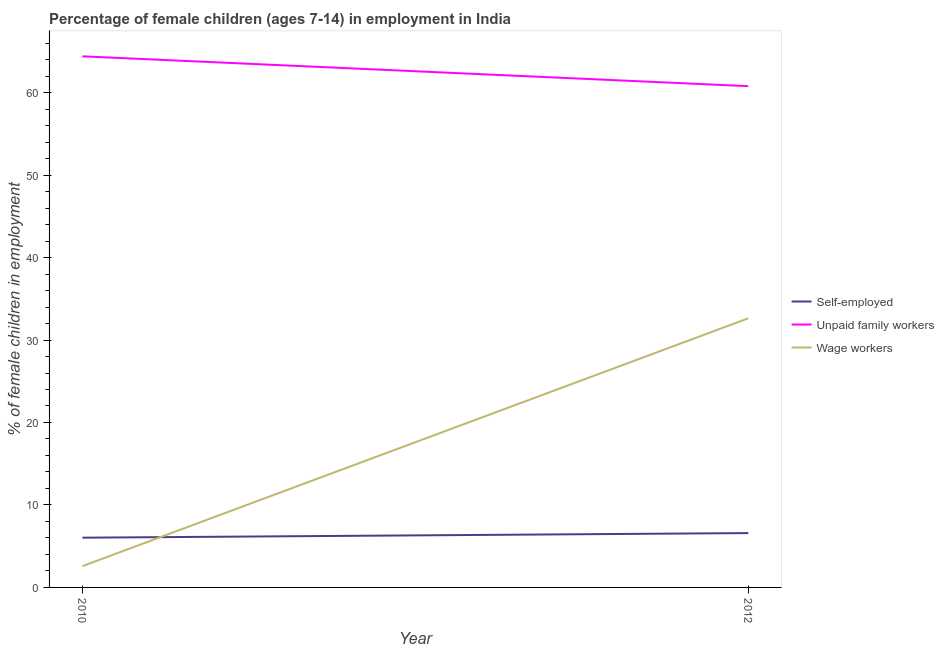How many different coloured lines are there?
Make the answer very short. 3. Is the number of lines equal to the number of legend labels?
Give a very brief answer. Yes. What is the percentage of children employed as unpaid family workers in 2010?
Your response must be concise. 64.4. Across all years, what is the maximum percentage of children employed as wage workers?
Offer a very short reply. 32.63. Across all years, what is the minimum percentage of self employed children?
Offer a very short reply. 6.03. In which year was the percentage of self employed children minimum?
Provide a short and direct response. 2010. What is the total percentage of children employed as wage workers in the graph?
Provide a short and direct response. 35.21. What is the difference between the percentage of children employed as wage workers in 2010 and that in 2012?
Your response must be concise. -30.05. What is the difference between the percentage of self employed children in 2010 and the percentage of children employed as wage workers in 2012?
Provide a short and direct response. -26.6. What is the average percentage of self employed children per year?
Offer a very short reply. 6.31. In the year 2010, what is the difference between the percentage of children employed as wage workers and percentage of self employed children?
Your answer should be very brief. -3.45. What is the ratio of the percentage of self employed children in 2010 to that in 2012?
Ensure brevity in your answer.  0.92. In how many years, is the percentage of children employed as wage workers greater than the average percentage of children employed as wage workers taken over all years?
Provide a succinct answer. 1. Is the percentage of self employed children strictly less than the percentage of children employed as unpaid family workers over the years?
Provide a succinct answer. Yes. How many years are there in the graph?
Provide a succinct answer. 2. What is the difference between two consecutive major ticks on the Y-axis?
Make the answer very short. 10. Does the graph contain any zero values?
Your response must be concise. No. What is the title of the graph?
Ensure brevity in your answer.  Percentage of female children (ages 7-14) in employment in India. Does "Ages 60+" appear as one of the legend labels in the graph?
Your response must be concise. No. What is the label or title of the X-axis?
Ensure brevity in your answer.  Year. What is the label or title of the Y-axis?
Keep it short and to the point. % of female children in employment. What is the % of female children in employment of Self-employed in 2010?
Offer a terse response. 6.03. What is the % of female children in employment of Unpaid family workers in 2010?
Your response must be concise. 64.4. What is the % of female children in employment of Wage workers in 2010?
Give a very brief answer. 2.58. What is the % of female children in employment in Self-employed in 2012?
Offer a terse response. 6.59. What is the % of female children in employment of Unpaid family workers in 2012?
Keep it short and to the point. 60.78. What is the % of female children in employment in Wage workers in 2012?
Offer a terse response. 32.63. Across all years, what is the maximum % of female children in employment of Self-employed?
Keep it short and to the point. 6.59. Across all years, what is the maximum % of female children in employment of Unpaid family workers?
Offer a terse response. 64.4. Across all years, what is the maximum % of female children in employment in Wage workers?
Offer a very short reply. 32.63. Across all years, what is the minimum % of female children in employment of Self-employed?
Provide a short and direct response. 6.03. Across all years, what is the minimum % of female children in employment in Unpaid family workers?
Provide a short and direct response. 60.78. Across all years, what is the minimum % of female children in employment of Wage workers?
Keep it short and to the point. 2.58. What is the total % of female children in employment of Self-employed in the graph?
Give a very brief answer. 12.62. What is the total % of female children in employment of Unpaid family workers in the graph?
Your answer should be compact. 125.18. What is the total % of female children in employment in Wage workers in the graph?
Your answer should be very brief. 35.21. What is the difference between the % of female children in employment of Self-employed in 2010 and that in 2012?
Ensure brevity in your answer.  -0.56. What is the difference between the % of female children in employment in Unpaid family workers in 2010 and that in 2012?
Give a very brief answer. 3.62. What is the difference between the % of female children in employment of Wage workers in 2010 and that in 2012?
Offer a very short reply. -30.05. What is the difference between the % of female children in employment of Self-employed in 2010 and the % of female children in employment of Unpaid family workers in 2012?
Ensure brevity in your answer.  -54.75. What is the difference between the % of female children in employment in Self-employed in 2010 and the % of female children in employment in Wage workers in 2012?
Offer a terse response. -26.6. What is the difference between the % of female children in employment in Unpaid family workers in 2010 and the % of female children in employment in Wage workers in 2012?
Ensure brevity in your answer.  31.77. What is the average % of female children in employment in Self-employed per year?
Keep it short and to the point. 6.31. What is the average % of female children in employment of Unpaid family workers per year?
Provide a succinct answer. 62.59. What is the average % of female children in employment in Wage workers per year?
Your answer should be compact. 17.61. In the year 2010, what is the difference between the % of female children in employment in Self-employed and % of female children in employment in Unpaid family workers?
Your answer should be compact. -58.37. In the year 2010, what is the difference between the % of female children in employment of Self-employed and % of female children in employment of Wage workers?
Ensure brevity in your answer.  3.45. In the year 2010, what is the difference between the % of female children in employment of Unpaid family workers and % of female children in employment of Wage workers?
Ensure brevity in your answer.  61.82. In the year 2012, what is the difference between the % of female children in employment in Self-employed and % of female children in employment in Unpaid family workers?
Give a very brief answer. -54.19. In the year 2012, what is the difference between the % of female children in employment in Self-employed and % of female children in employment in Wage workers?
Offer a very short reply. -26.04. In the year 2012, what is the difference between the % of female children in employment in Unpaid family workers and % of female children in employment in Wage workers?
Your answer should be very brief. 28.15. What is the ratio of the % of female children in employment in Self-employed in 2010 to that in 2012?
Your answer should be very brief. 0.92. What is the ratio of the % of female children in employment of Unpaid family workers in 2010 to that in 2012?
Provide a short and direct response. 1.06. What is the ratio of the % of female children in employment in Wage workers in 2010 to that in 2012?
Your answer should be compact. 0.08. What is the difference between the highest and the second highest % of female children in employment in Self-employed?
Offer a terse response. 0.56. What is the difference between the highest and the second highest % of female children in employment of Unpaid family workers?
Your answer should be compact. 3.62. What is the difference between the highest and the second highest % of female children in employment of Wage workers?
Ensure brevity in your answer.  30.05. What is the difference between the highest and the lowest % of female children in employment in Self-employed?
Provide a succinct answer. 0.56. What is the difference between the highest and the lowest % of female children in employment in Unpaid family workers?
Give a very brief answer. 3.62. What is the difference between the highest and the lowest % of female children in employment of Wage workers?
Offer a very short reply. 30.05. 